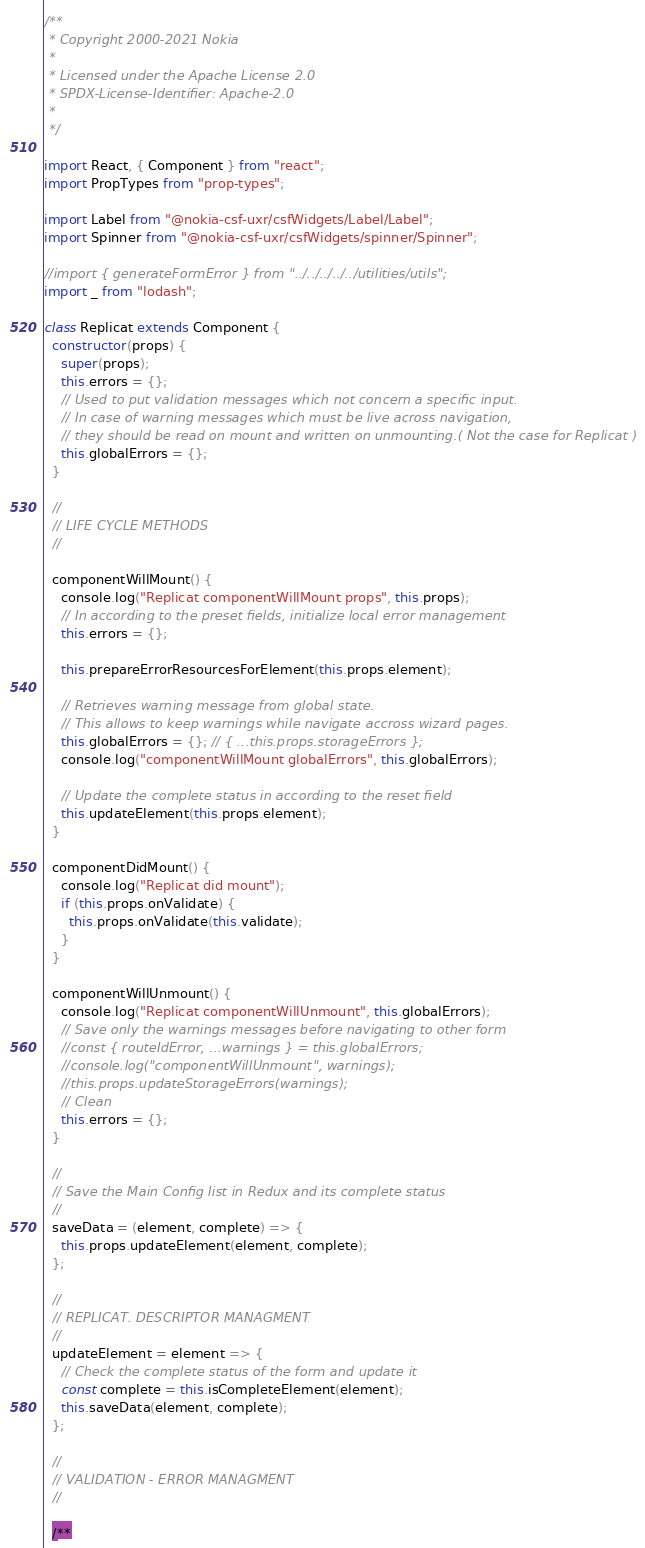Convert code to text. <code><loc_0><loc_0><loc_500><loc_500><_JavaScript_>/**
 * Copyright 2000-2021 Nokia
 *
 * Licensed under the Apache License 2.0
 * SPDX-License-Identifier: Apache-2.0
 *
 */

import React, { Component } from "react";
import PropTypes from "prop-types";

import Label from "@nokia-csf-uxr/csfWidgets/Label/Label";
import Spinner from "@nokia-csf-uxr/csfWidgets/spinner/Spinner";

//import { generateFormError } from "../../../../../utilities/utils";
import _ from "lodash";

class Replicat extends Component {
  constructor(props) {
    super(props);
    this.errors = {};
    // Used to put validation messages which not concern a specific input.
    // In case of warning messages which must be live across navigation,
    // they should be read on mount and written on unmounting.( Not the case for Replicat )
    this.globalErrors = {};
  }

  //
  // LIFE CYCLE METHODS
  //

  componentWillMount() {
    console.log("Replicat componentWillMount props", this.props);
    // In according to the preset fields, initialize local error management
    this.errors = {};

    this.prepareErrorResourcesForElement(this.props.element);

    // Retrieves warning message from global state.
    // This allows to keep warnings while navigate accross wizard pages.
    this.globalErrors = {}; // { ...this.props.storageErrors };
    console.log("componentWillMount globalErrors", this.globalErrors);

    // Update the complete status in according to the reset field
    this.updateElement(this.props.element);
  }

  componentDidMount() {
    console.log("Replicat did mount");
    if (this.props.onValidate) {
      this.props.onValidate(this.validate);
    }
  }

  componentWillUnmount() {
    console.log("Replicat componentWillUnmount", this.globalErrors);
    // Save only the warnings messages before navigating to other form
    //const { routeIdError, ...warnings } = this.globalErrors;
    //console.log("componentWillUnmount", warnings);
    //this.props.updateStorageErrors(warnings);
    // Clean
    this.errors = {};
  }

  //
  // Save the Main Config list in Redux and its complete status
  //
  saveData = (element, complete) => {
    this.props.updateElement(element, complete);
  };

  //
  // REPLICAT. DESCRIPTOR MANAGMENT
  //
  updateElement = element => {
    // Check the complete status of the form and update it
    const complete = this.isCompleteElement(element);
    this.saveData(element, complete);
  };

  //
  // VALIDATION - ERROR MANAGMENT
  //

  /**</code> 